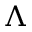<formula> <loc_0><loc_0><loc_500><loc_500>\Lambda</formula> 